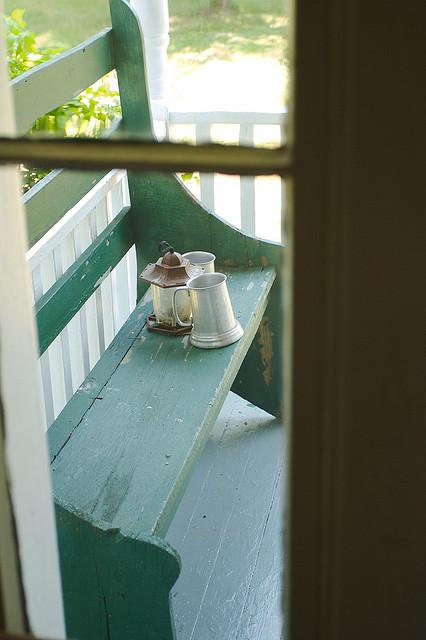What type of drinking vessels are on the bench? mugs 